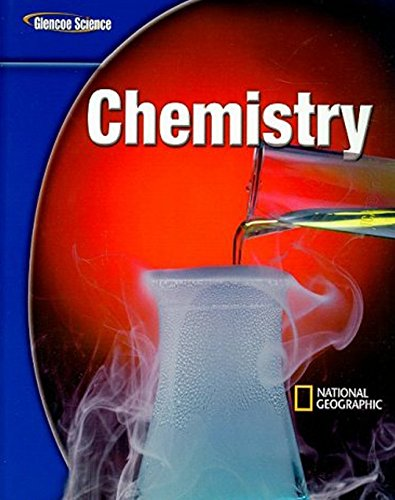What is the title of this book? The title of this book is 'Chemistry', part of the 'Glencoe Science' series, in collaboration with National Geographic. 